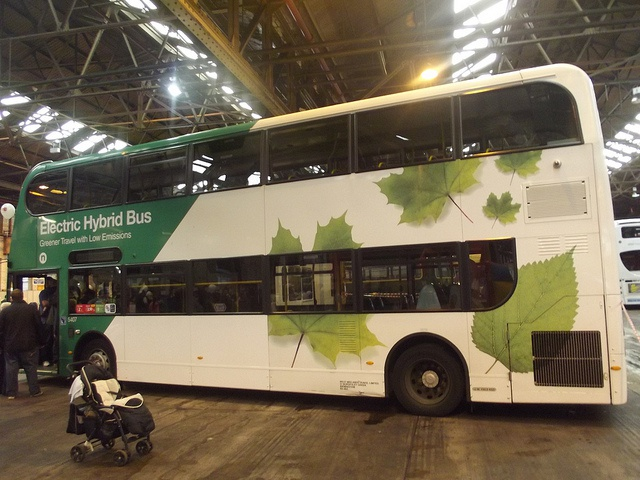Describe the objects in this image and their specific colors. I can see bus in black, tan, and olive tones, people in black, maroon, and gray tones, and people in black, maroon, and gray tones in this image. 